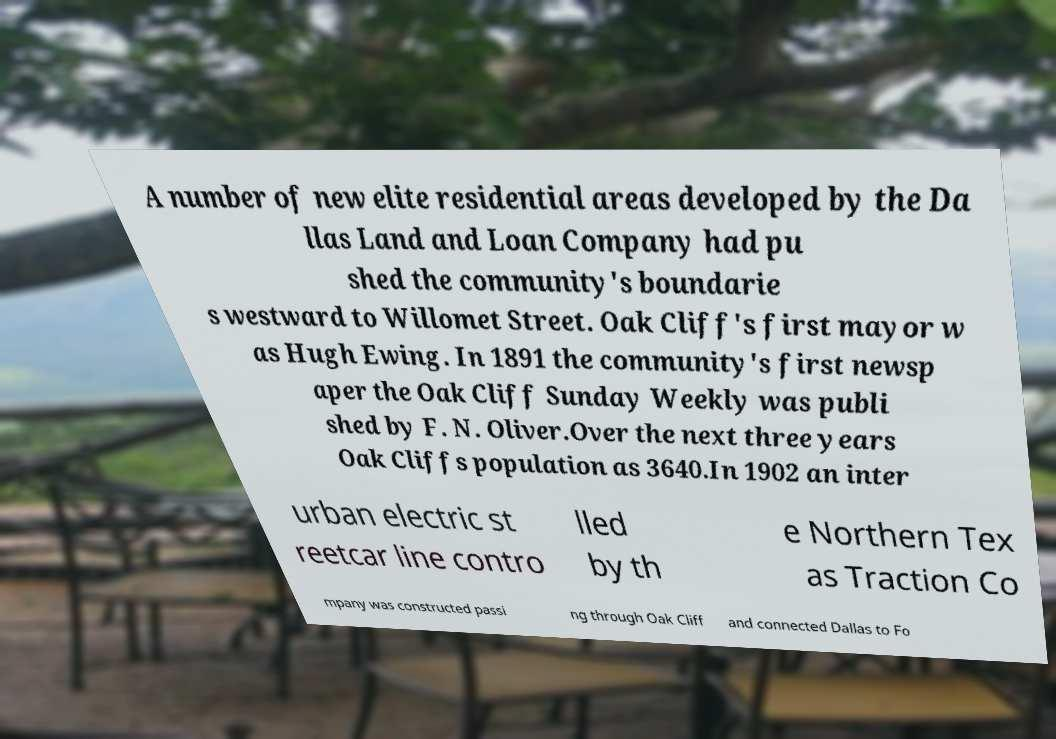There's text embedded in this image that I need extracted. Can you transcribe it verbatim? A number of new elite residential areas developed by the Da llas Land and Loan Company had pu shed the community's boundarie s westward to Willomet Street. Oak Cliff's first mayor w as Hugh Ewing. In 1891 the community's first newsp aper the Oak Cliff Sunday Weekly was publi shed by F. N. Oliver.Over the next three years Oak Cliffs population as 3640.In 1902 an inter urban electric st reetcar line contro lled by th e Northern Tex as Traction Co mpany was constructed passi ng through Oak Cliff and connected Dallas to Fo 